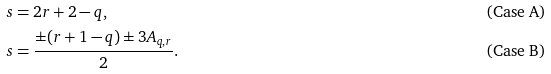<formula> <loc_0><loc_0><loc_500><loc_500>s & = 2 r + 2 - q , & & \text {(Case A)} \\ s & = \frac { \pm ( r + 1 - q ) \pm 3 A _ { q , r } } { 2 } . & & \text {(Case B)}</formula> 